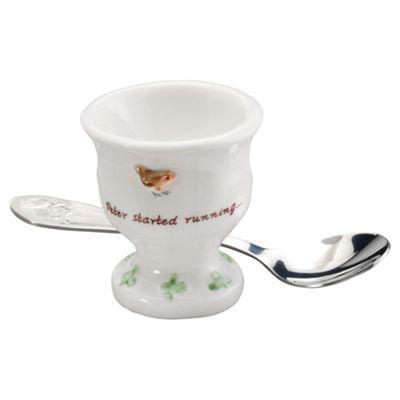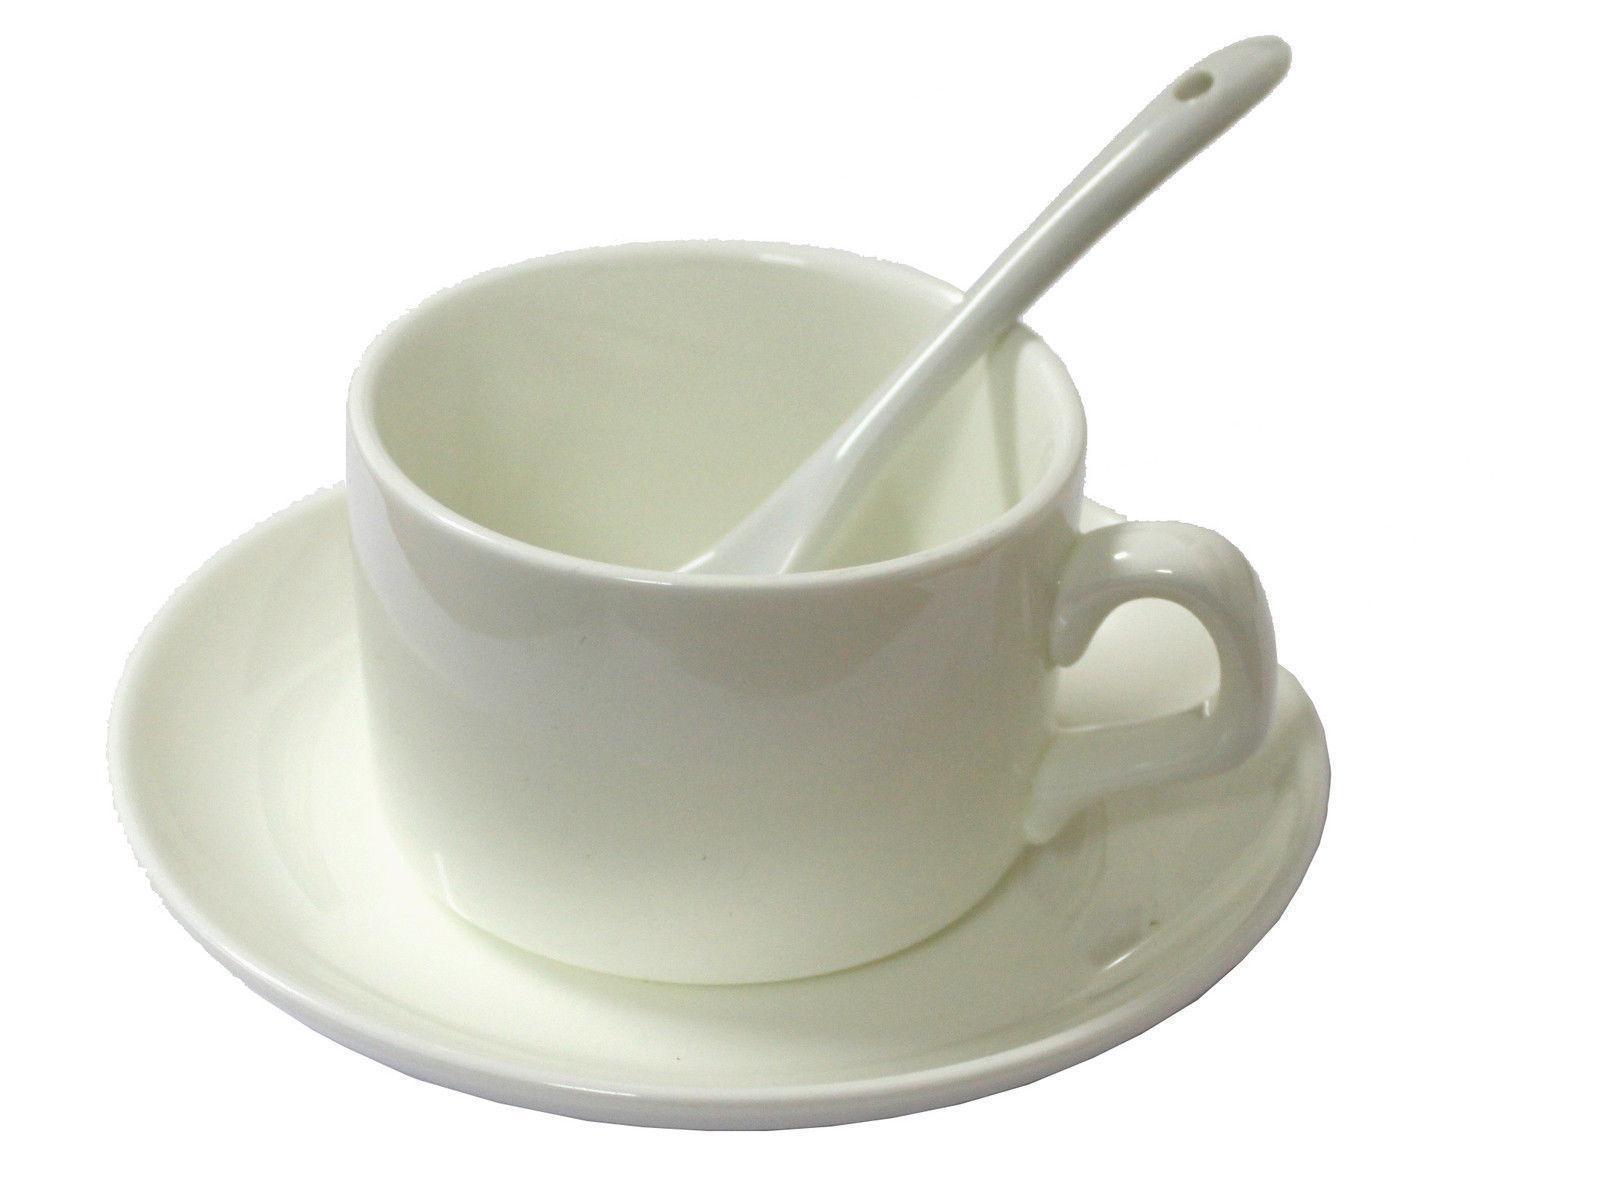The first image is the image on the left, the second image is the image on the right. For the images shown, is this caption "Steam is visible in one of the images." true? Answer yes or no. No. The first image is the image on the left, the second image is the image on the right. Examine the images to the left and right. Is the description "In 1 of the images, an empty cup has a spoon in it." accurate? Answer yes or no. Yes. 